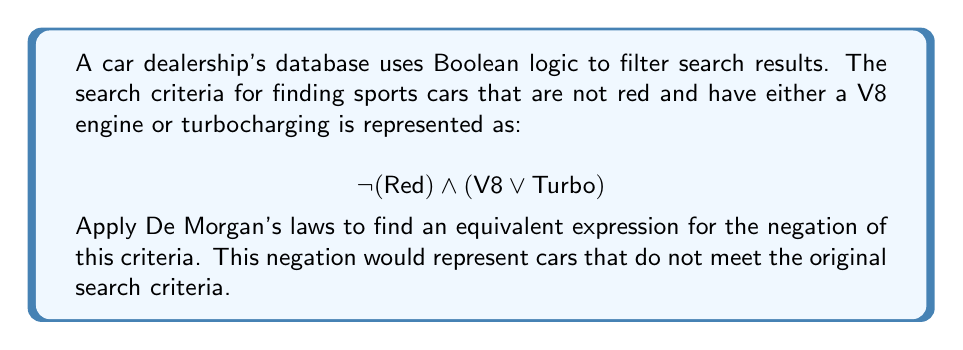Could you help me with this problem? Let's apply De Morgan's laws step by step to negate the given expression:

1) Start with the original expression:
   $$ \neg(\text{Red}) \land (\text{V8} \lor \text{Turbo}) $$

2) To negate the entire expression, we use De Morgan's first law:
   $$ \neg[\neg(\text{Red}) \land (\text{V8} \lor \text{Turbo})] $$
   $$ = \neg[\neg(\text{Red})] \lor \neg[(\text{V8} \lor \text{Turbo})] $$

3) Simplify the double negation:
   $$ = \text{Red} \lor \neg[(\text{V8} \lor \text{Turbo})] $$

4) Apply De Morgan's second law to the second term:
   $$ = \text{Red} \lor [\neg(\text{V8}) \land \neg(\text{Turbo})] $$

5) The final equivalent expression is:
   $$ \text{Red} \lor (\neg\text{V8} \land \neg\text{Turbo}) $$

This expression represents cars that are either red, or neither have a V8 engine nor turbocharging.
Answer: $$ \text{Red} \lor (\neg\text{V8} \land \neg\text{Turbo}) $$ 